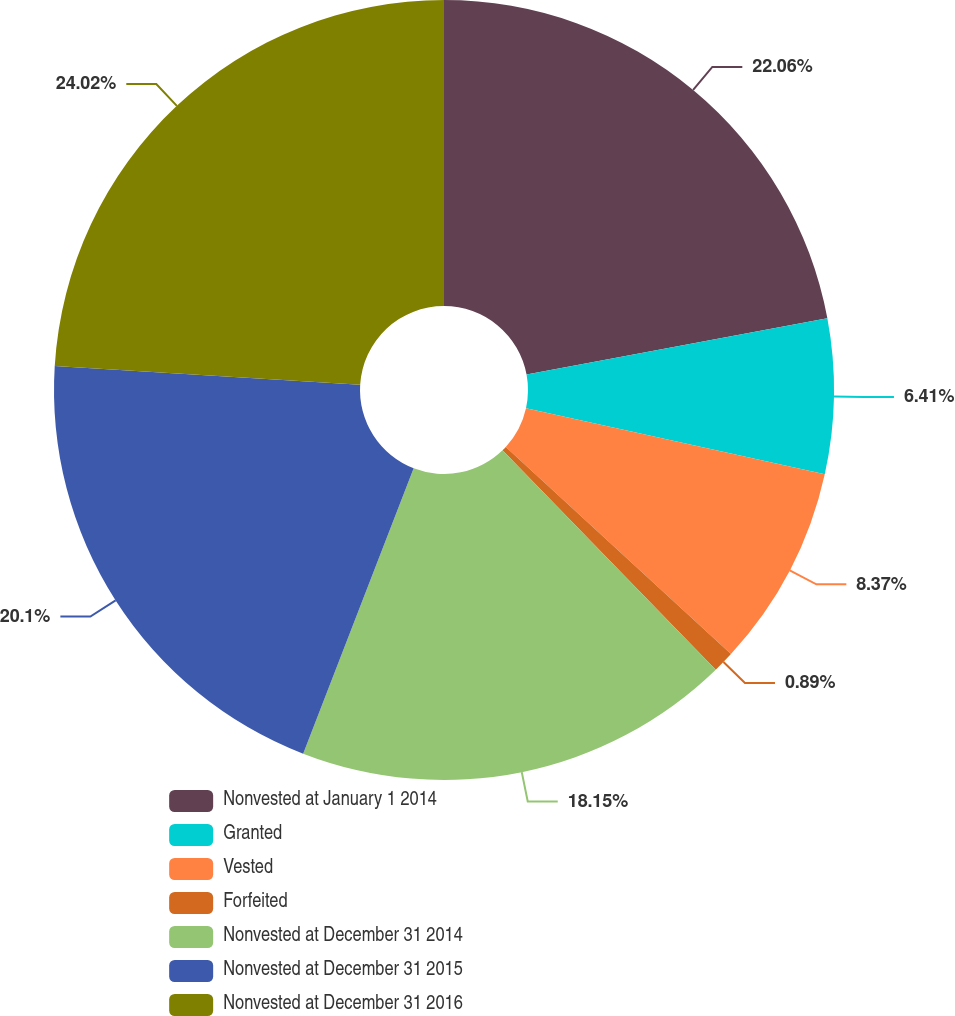<chart> <loc_0><loc_0><loc_500><loc_500><pie_chart><fcel>Nonvested at January 1 2014<fcel>Granted<fcel>Vested<fcel>Forfeited<fcel>Nonvested at December 31 2014<fcel>Nonvested at December 31 2015<fcel>Nonvested at December 31 2016<nl><fcel>22.06%<fcel>6.41%<fcel>8.37%<fcel>0.89%<fcel>18.15%<fcel>20.1%<fcel>24.02%<nl></chart> 